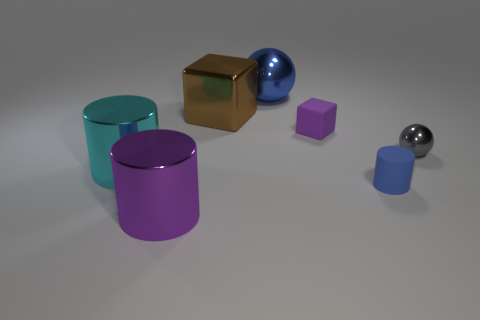Subtract all purple cylinders. How many cylinders are left? 2 Subtract 1 cylinders. How many cylinders are left? 2 Add 3 red rubber objects. How many objects exist? 10 Subtract all cubes. How many objects are left? 5 Add 1 large things. How many large things are left? 5 Add 2 metal cylinders. How many metal cylinders exist? 4 Subtract 0 blue cubes. How many objects are left? 7 Subtract all big metallic cylinders. Subtract all tiny shiny objects. How many objects are left? 4 